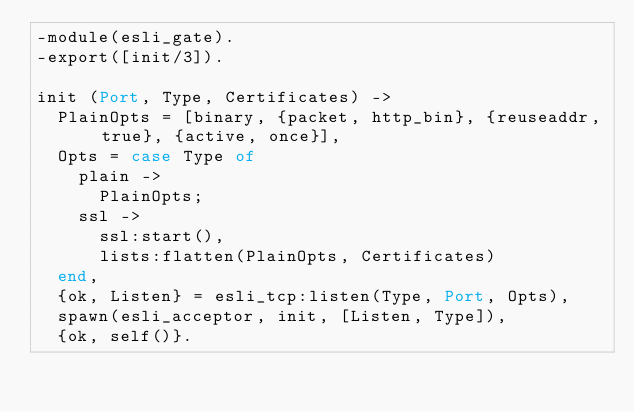Convert code to text. <code><loc_0><loc_0><loc_500><loc_500><_Erlang_>-module(esli_gate).
-export([init/3]).

init (Port, Type, Certificates) ->
  PlainOpts = [binary, {packet, http_bin}, {reuseaddr, true}, {active, once}],
  Opts = case Type of
    plain ->
      PlainOpts;
    ssl ->
      ssl:start(),
      lists:flatten(PlainOpts, Certificates)
  end,
  {ok, Listen} = esli_tcp:listen(Type, Port, Opts),
  spawn(esli_acceptor, init, [Listen, Type]),
  {ok, self()}.
</code> 